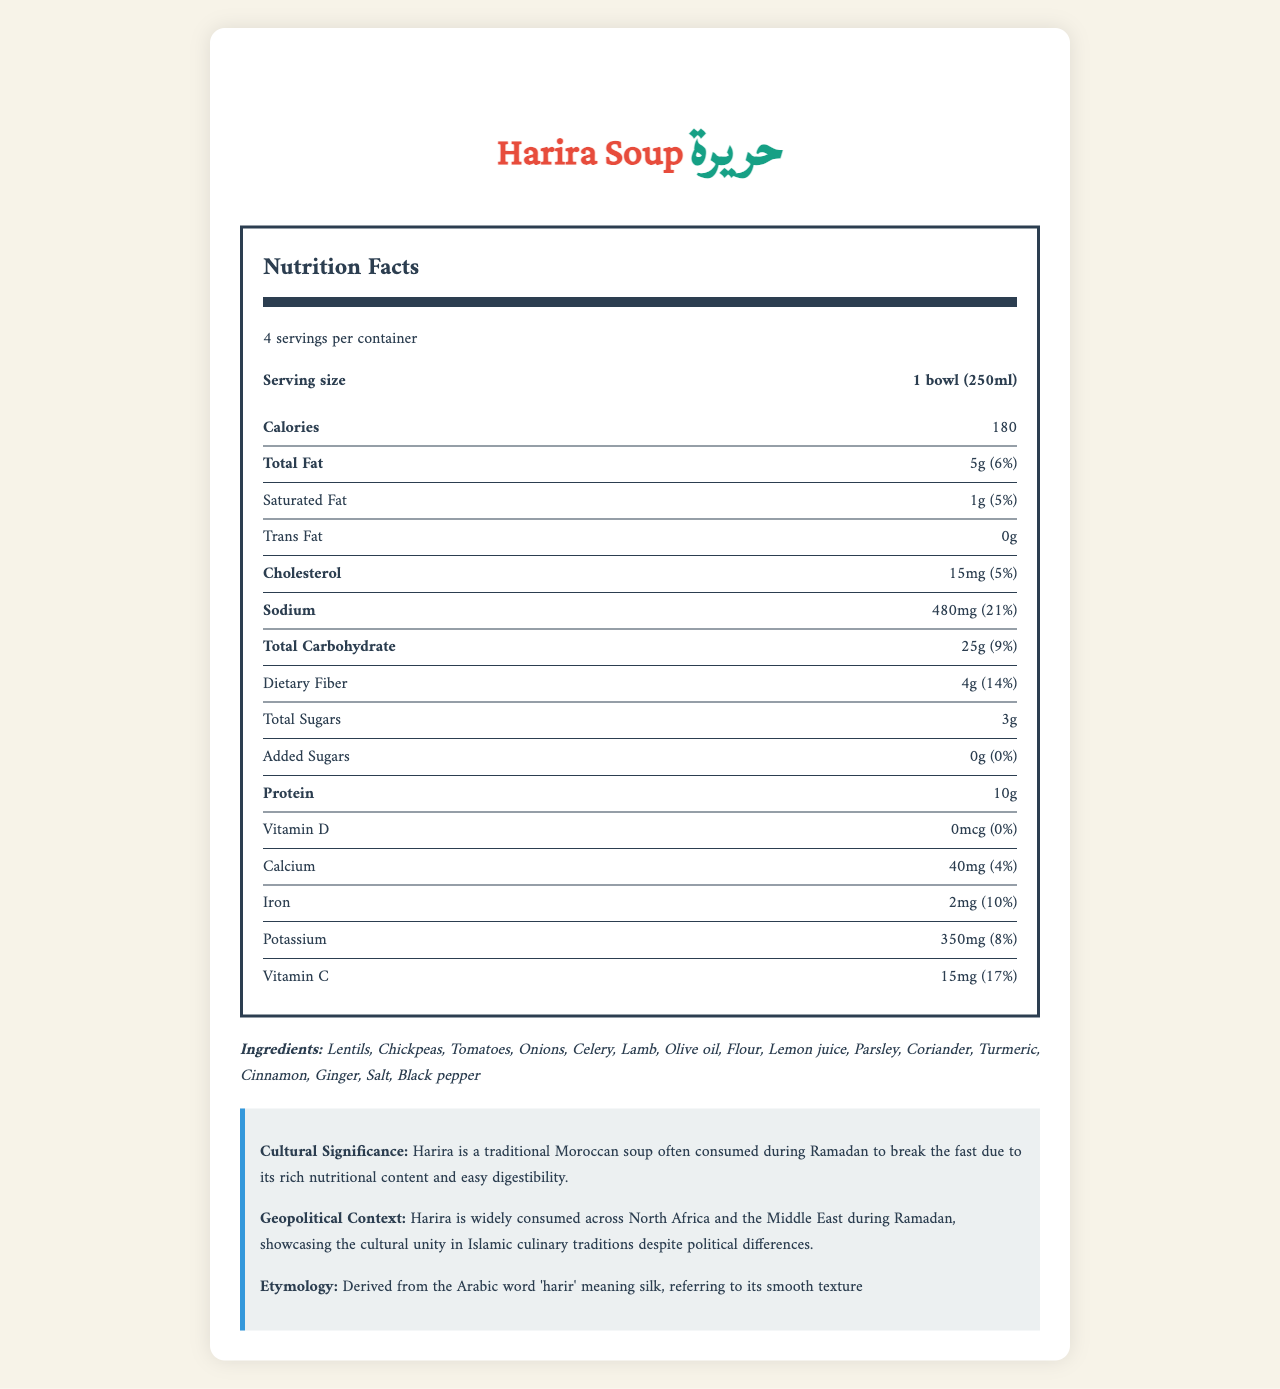what is the serving size for Harira Soup? The serving size is clearly stated as 1 bowl (250ml) in the Nutrition Facts section.
Answer: 1 bowl (250ml) how many servings are there per container? The document specifies that there are 4 servings per container.
Answer: 4 how many calories are in one serving of Harira Soup? The calorie count per serving is listed as 180.
Answer: 180 how much total fat is in one serving, and what is its daily value percentage? The total fat content per serving is listed as 5 grams, which constitutes 6% of the daily value.
Answer: 5g (6%) which nutrient contributes the most to the daily value percentage? Sodium has the highest daily value percentage, at 21%, compared to other nutrients.
Answer: Sodium (21%) which ingredient is an allergen in Harira Soup? A. Lentils B. Wheat C. Lamb D. Ginger The document specifies that wheat (flour) is an allergen contained in the soup.
Answer: B how much cholesterol is in one serving of Harira Soup? A. 10mg B. 15mg C. 20mg D. 25mg The document indicates that one serving contains 15mg of cholesterol.
Answer: B does Harira Soup contain any trans fat? The document explicitly states that the trans fat content is 0 grams.
Answer: No how should Harira Soup be prepared? The preparation instructions are to heat and serve, ideally with dates and water for breaking the fast.
Answer: Heat and serve. Best consumed with dates and water for breaking the fast. what is the cultural significance of Harira Soup? The cultural significance is described in the document, highlighting its traditional use during Ramadan.
Answer: Harira is a traditional Moroccan soup often consumed during Ramadan to break the fast due to its rich nutritional content and easy digestibility. how many grams of protein are in one serving? The protein content per serving is specified as 10 grams.
Answer: 10g is there any added sugar in Harira Soup? The document indicates that the amount of added sugars is 0 grams.
Answer: No what is the origin of the word "Harira"? The etymology section states that Harira is derived from the Arabic word 'harir', meaning silk, which describes its smooth texture.
Answer: Derived from the Arabic word 'harir' meaning silk, referring to its smooth texture summarize the nutrition information provided for Harira Soup The summary includes all the main nutritional facts presented in the document.
Answer: Harira Soup has 180 calories per serving, 5g of total fat, 1g of saturated fat, no trans fat, 15mg of cholesterol, 480mg of sodium, 25g of total carbohydrates, 4g of dietary fiber, 3g total sugars (no added sugars), and 10g of protein. It also contains vitamins and minerals, including Vitamin D (0mcg), Calcium (40mg), Iron (2mg), Potassium (350mg), and Vitamin C (15mg). how much Vitamin D does one serving of Harira Soup contain? The document notes that there is no Vitamin D in one serving of Harira Soup.
Answer: 0mcg what are the ingredients in Harira Soup? The ingredients are listed in the ingredients section.
Answer: Lentils, Chickpeas, Tomatoes, Onions, Celery, Lamb, Olive oil, Flour, Lemon juice, Parsley, Coriander, Turmeric, Cinnamon, Ginger, Salt, Black pepper what is the recommended way to consume Harira during Ramadan? The document recommends consuming Harira with dates and water when breaking the fast during Ramadan.
Answer: Best consumed with dates and water for breaking the fast. is the exact recipe for Harira provided in the document? The document does not provide the exact recipe; it only lists ingredients and preparation instructions.
Answer: Not enough information what is the daily value percentage of Iron in one serving of Harira Soup? The daily value percentage of Iron is listed as 10%.
Answer: 10% which nutrient has the highest amount in milligrams? A. Calcium B. Potassium C. Iron D. Sodium Sodium has the highest amount at 480mg, compared to Calcium (40mg), Potassium (350mg), and Iron (2mg).
Answer: D 